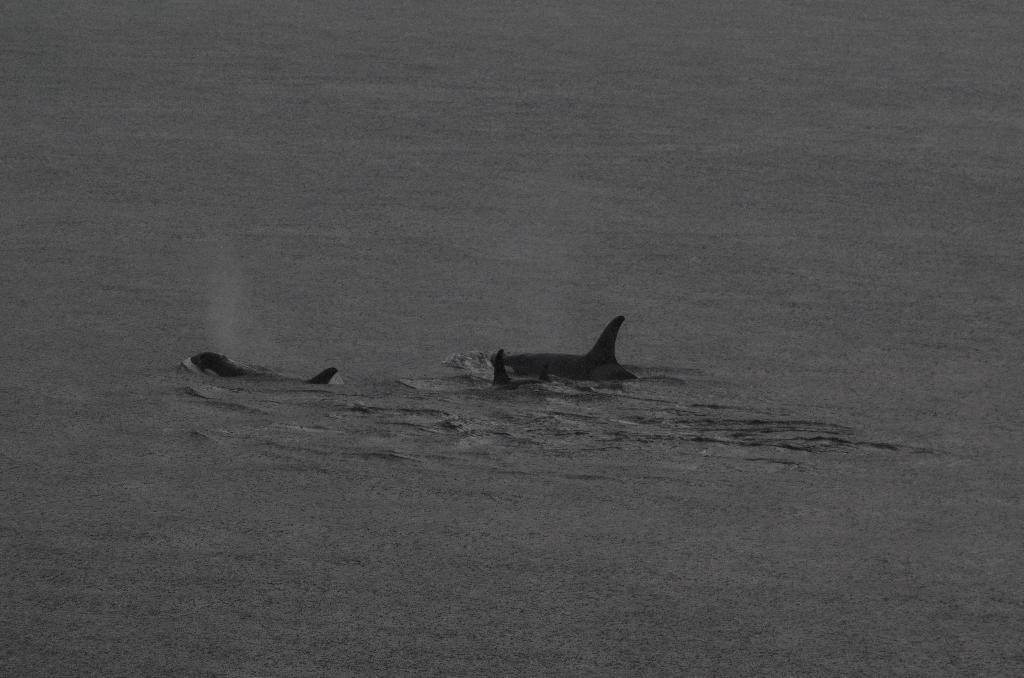Can you describe this image briefly? In this image we can see some sharks in the water, and the background is blurred. 